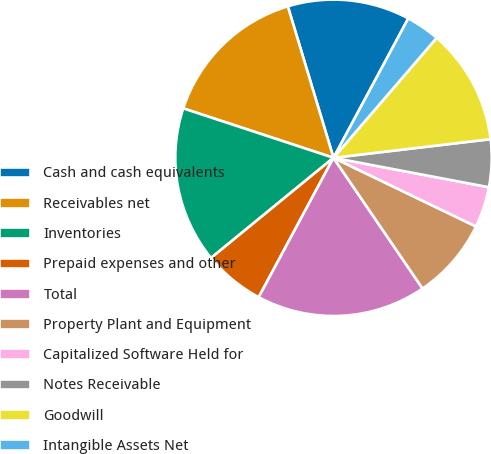Convert chart. <chart><loc_0><loc_0><loc_500><loc_500><pie_chart><fcel>Cash and cash equivalents<fcel>Receivables net<fcel>Inventories<fcel>Prepaid expenses and other<fcel>Total<fcel>Property Plant and Equipment<fcel>Capitalized Software Held for<fcel>Notes Receivable<fcel>Goodwill<fcel>Intangible Assets Net<nl><fcel>12.5%<fcel>15.28%<fcel>15.97%<fcel>6.25%<fcel>17.36%<fcel>8.33%<fcel>4.17%<fcel>4.86%<fcel>11.81%<fcel>3.47%<nl></chart> 